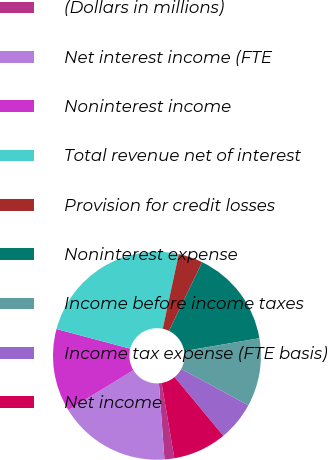<chart> <loc_0><loc_0><loc_500><loc_500><pie_chart><fcel>(Dollars in millions)<fcel>Net interest income (FTE<fcel>Noninterest income<fcel>Total revenue net of interest<fcel>Provision for credit losses<fcel>Noninterest expense<fcel>Income before income taxes<fcel>Income tax expense (FTE basis)<fcel>Net income<nl><fcel>1.53%<fcel>17.41%<fcel>12.88%<fcel>24.22%<fcel>3.8%<fcel>15.14%<fcel>10.61%<fcel>6.07%<fcel>8.34%<nl></chart> 